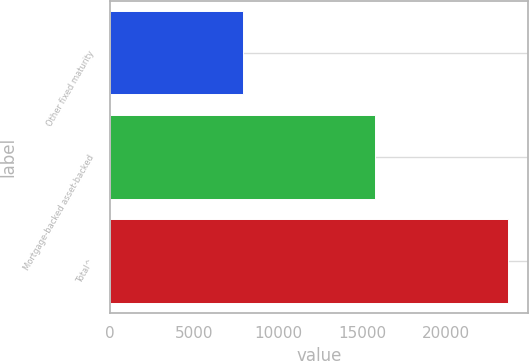Convert chart to OTSL. <chart><loc_0><loc_0><loc_500><loc_500><bar_chart><fcel>Other fixed maturity<fcel>Mortgage-backed asset-backed<fcel>Total^<nl><fcel>7915<fcel>15758<fcel>23673<nl></chart> 